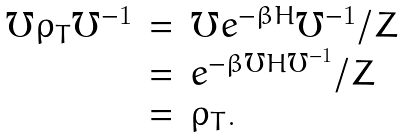Convert formula to latex. <formula><loc_0><loc_0><loc_500><loc_500>\begin{array} { l l l } \mho \rho _ { T } \mho ^ { - 1 } & = & \mho e ^ { - \beta H } \mho ^ { - 1 } / Z \\ & = & e ^ { - \beta \mho H \mho ^ { - 1 } } / Z \\ & = & \rho _ { T } . \, \end{array}</formula> 